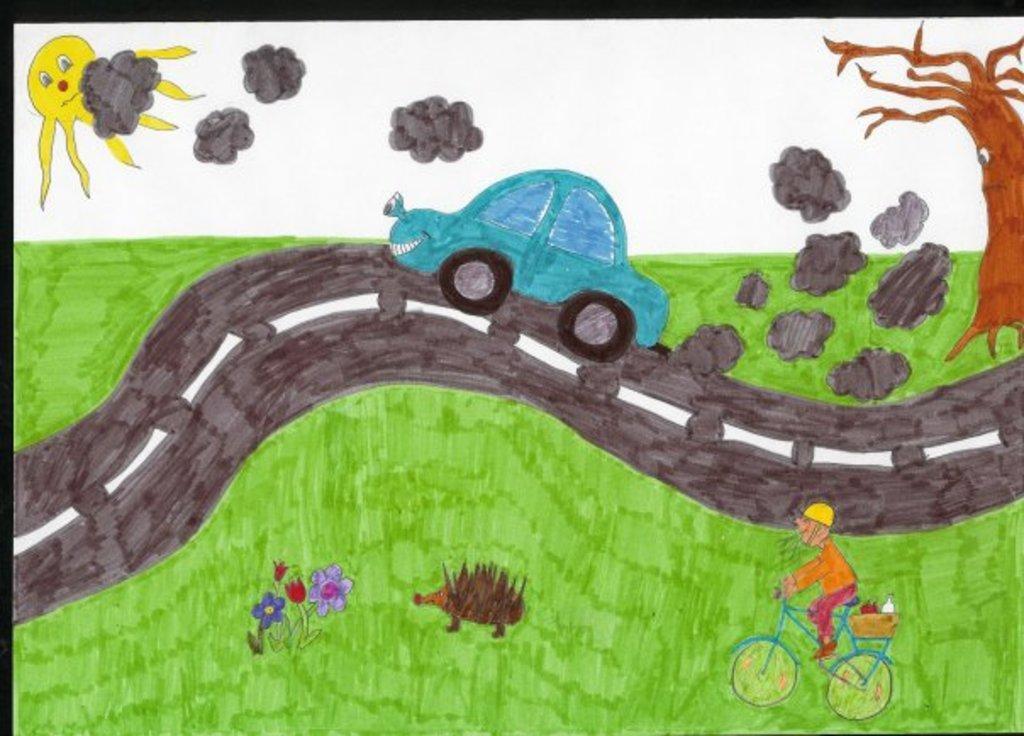How would you summarize this image in a sentence or two? This image consists of a painting on the paper. At the top of the image there is the sky. At the bottom of the image there is a ground with grass on it. On the right side of the image there is a tree. A man is riding on a bicycle and there is a road. In the middle of the image a car is moving on the road and there is smoke. There is a Porcupine and there are a few flowers on the ground. 